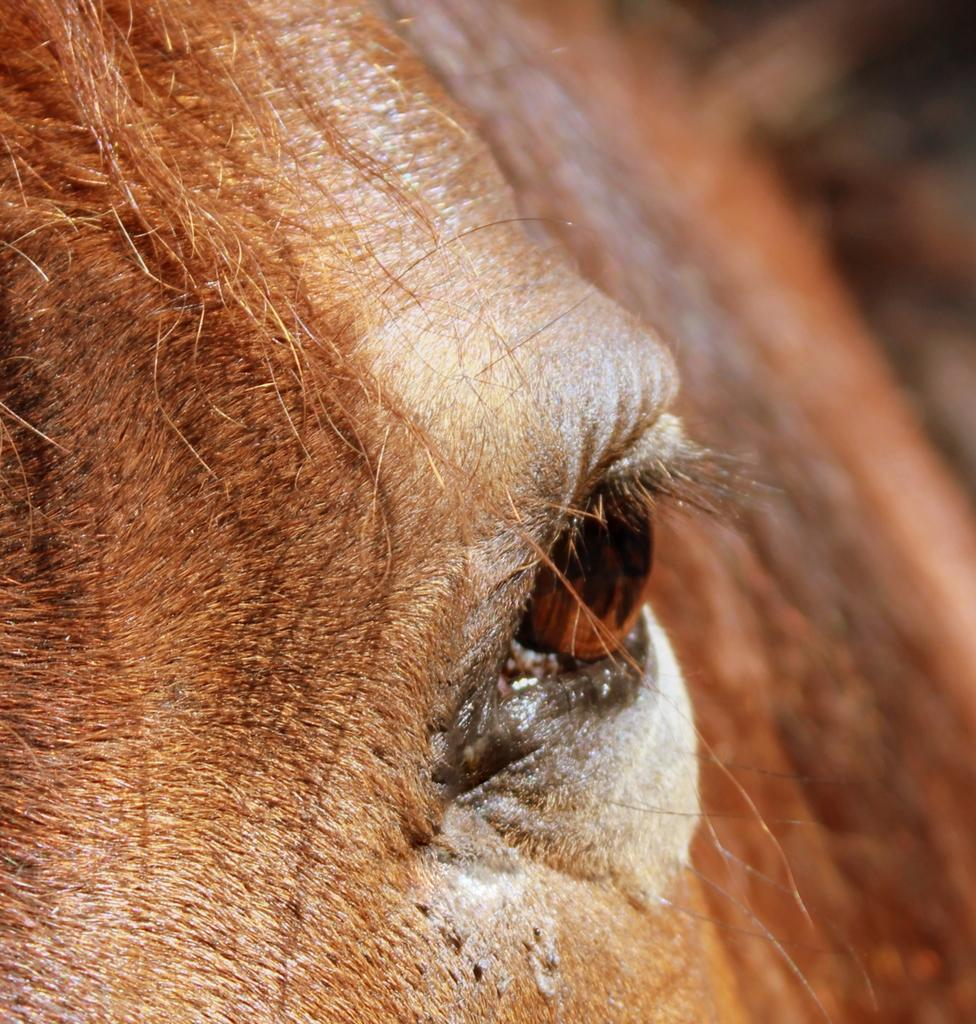What is the main focus of the image? The main focus of the image is an animal's eye in the middle of the image. What else can be seen on the left side of the image? There is the head of an animal on the left side of the image. How many trails can be seen coming from the animal's ears in the image? There are no trails visible in the image, as it only features an animal's eye and the head of an animal. What type of hands can be seen holding the animal's head in the image? There are no hands visible in the image; only the animal's eye and head are present. 